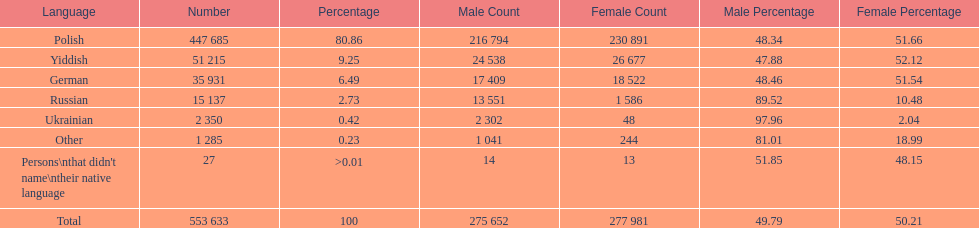How many speakers (of any language) are represented on the table ? 553 633. 